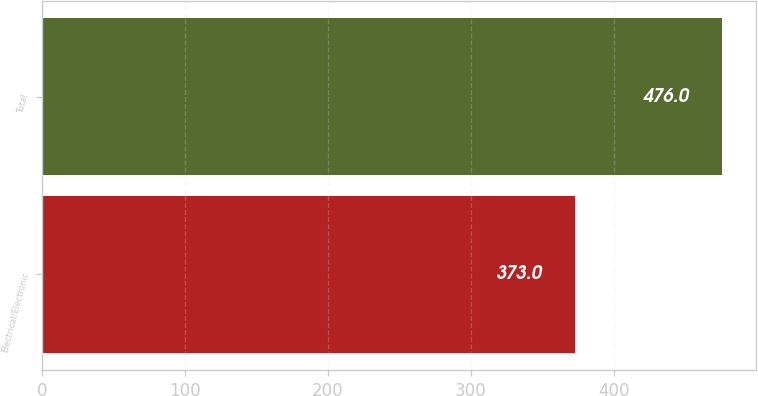Convert chart to OTSL. <chart><loc_0><loc_0><loc_500><loc_500><bar_chart><fcel>Electrical/Electronic<fcel>Total<nl><fcel>373<fcel>476<nl></chart> 